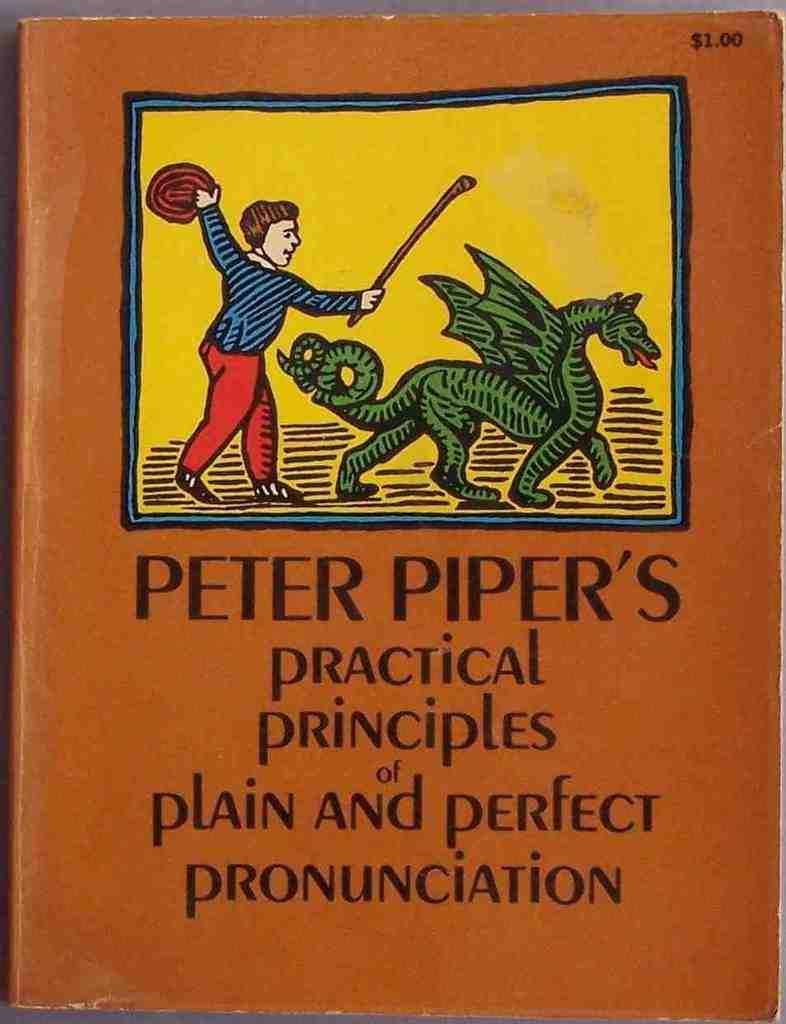What is the main subject of the image? The main subject of the image is the cover page of a book. What type of image is on the cover page? There is a cartoon picture on the cover page. Is there any text on the cover page? Yes, there is text at the bottom of the picture. What type of scale can be seen in the image? There is no scale present in the image; it features the cover page of a book with a cartoon picture and text at the bottom. What verse is written on the cover page? There is no verse present on the cover page; it only has a cartoon picture and text at the bottom. 